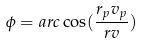<formula> <loc_0><loc_0><loc_500><loc_500>\phi = a r c \cos ( \frac { r _ { p } v _ { p } } { r v } )</formula> 